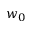<formula> <loc_0><loc_0><loc_500><loc_500>w _ { 0 }</formula> 